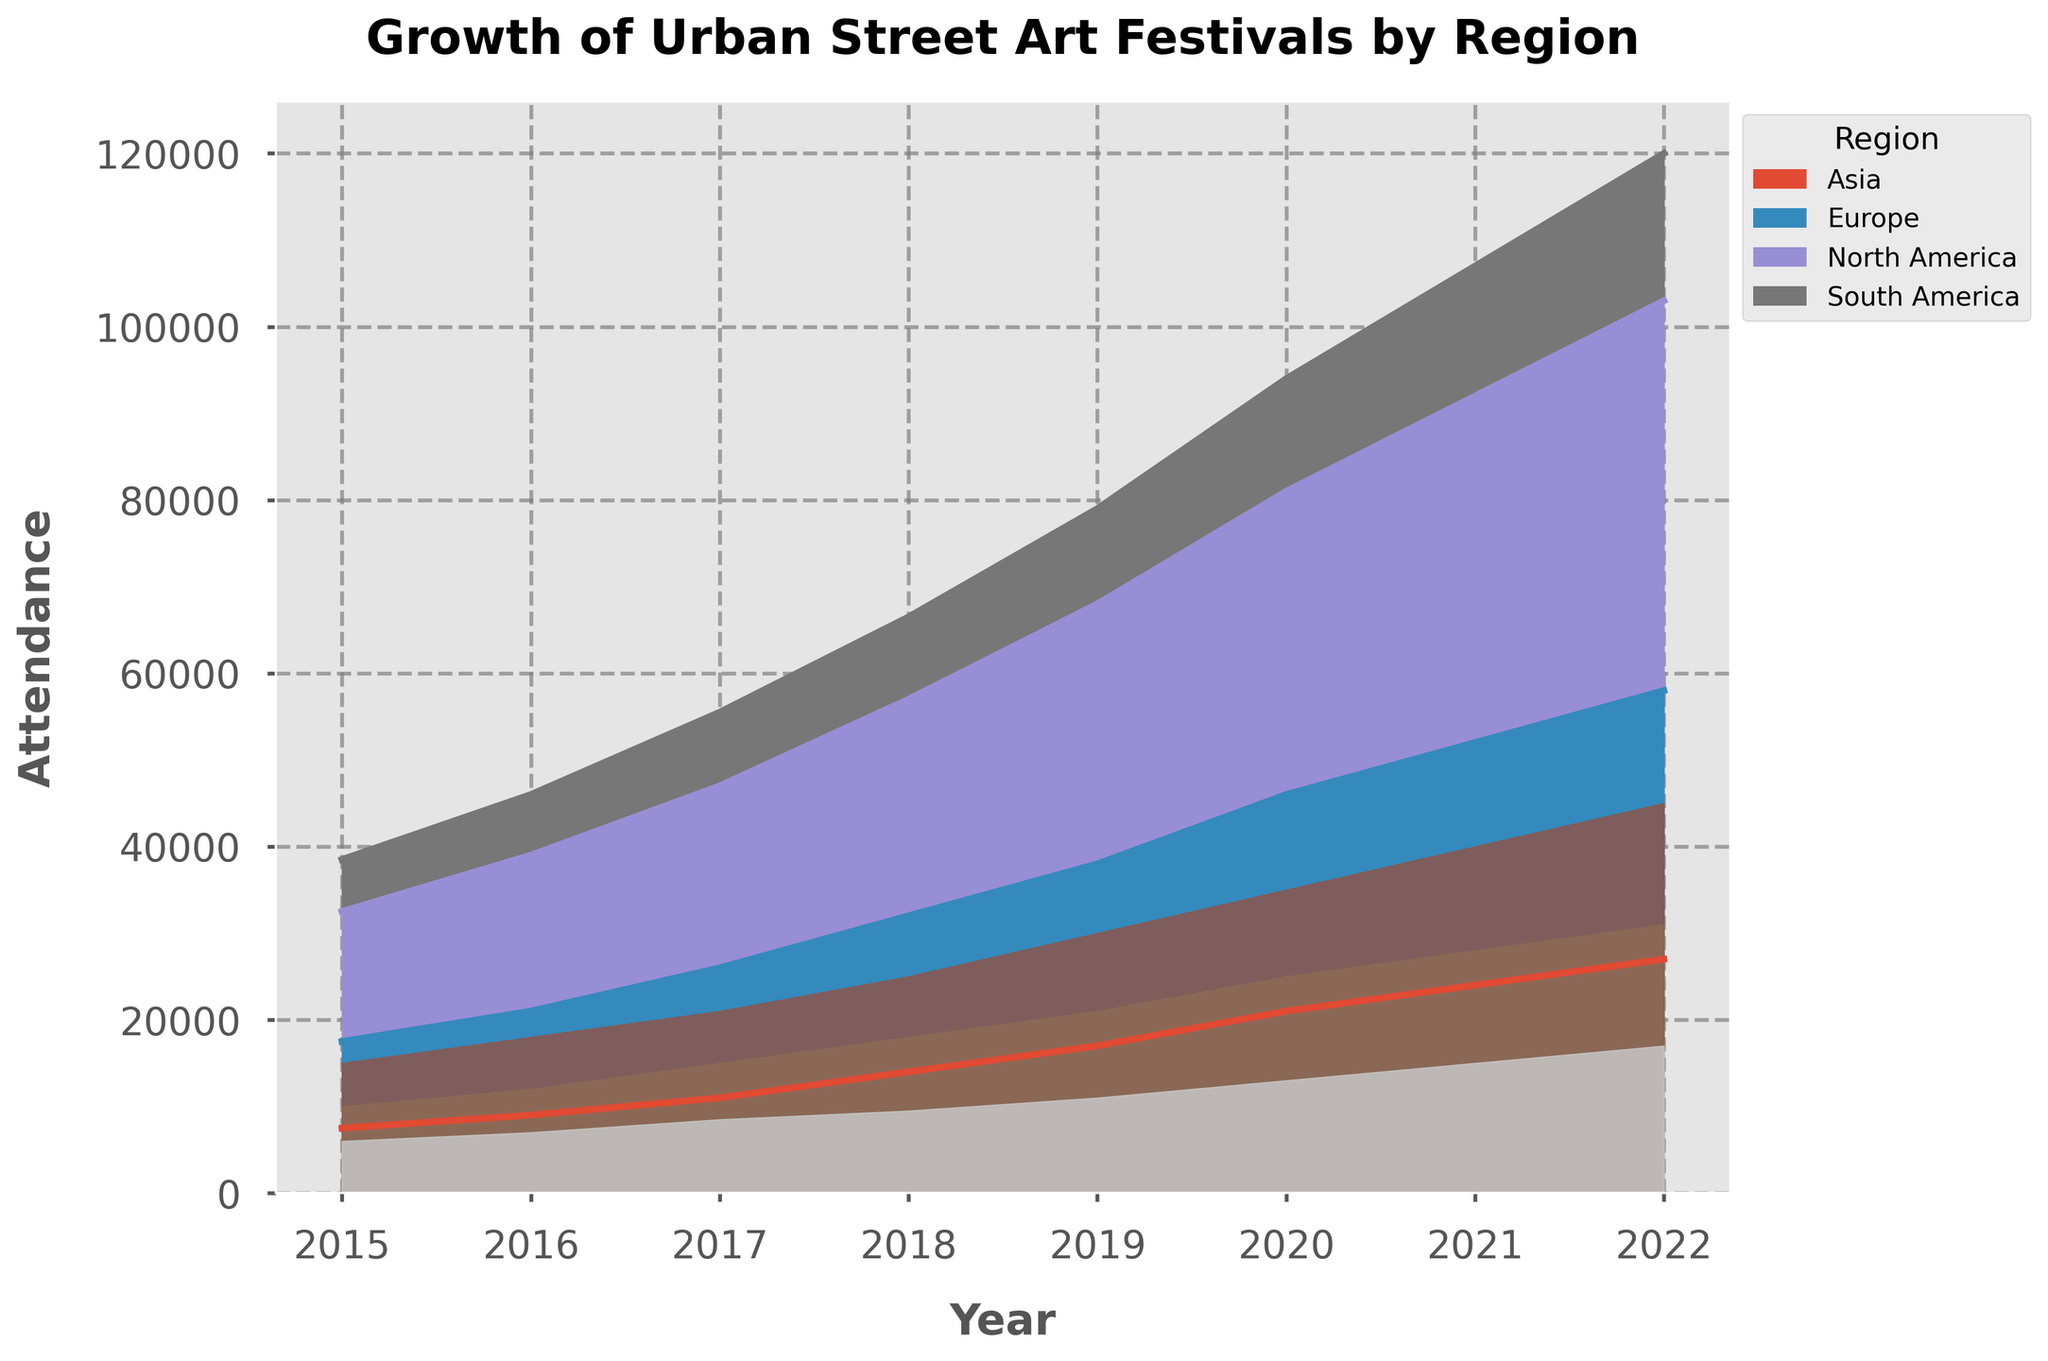What is the overall trend in attendance for Urban Street Art Festivals in North America from 2015 to 2022? By observing the North American section of the area chart, you can see that the attendance is increasing each year from 2015 to 2022. The trend is upwards.
Answer: Increasing Which year had the highest total attendance across all regions? Looking at the total height of all stacked areas combined, 2022 appears to have the highest attendance among all regions.
Answer: 2022 Compare the attendance growth between Europe and South America from 2015 to 2022. Which region experienced more growth? In 2015, Europe had an attendance of 10,000, and in 2022, it had 31,000, showing an increase of 21,000. South America had 6,000 in 2015 and 17,000 in 2022, an increase of 11,000. Therefore, Europe had a larger growth.
Answer: Europe Calculate the average attendance growth per year for Asia between 2015 and 2022. The attendance in Asia grew from 7,500 in 2015 to 27,000 in 2022: the growth is 19,500. To find the average annual growth, divide 19,500 by the number of years (7). 19,500 / 7 = 2,785.71.
Answer: 2,785.71 How does the attendance for South America in 2019 compare to that in 2022? South America's attendance was 11,000 in 2019 and 17,000 in 2022. Therefore, the attendance increased by 6,000 between these years.
Answer: Increased by 6,000 Between which consecutive years did North America experience the highest increase in attendance? By comparing the differences in North America's attendance between consecutive years: 2015-2016 (3,000), 2016-2017 (3,000), 2017-2018 (4,000), 2018-2019 (5,000), 2019-2020 (5,000), 2020-2021 (5,000), 2021-2022 (5,000), it is clear that the largest increase (5,000) occurred between 2019 and 2020 as well as in the next consecutive years (2020-2021 and 2021-2022).
Answer: 2019-2020 In 2018, which region had the highest attendance and how much higher was it compared to the region with the lowest attendance? From the chart, North America had the highest attendance in 2018 with 25,000, while South America had the lowest with 9,500. The difference is 25,000 - 9,500 = 15,500.
Answer: North America, 15,500 What percentage of the total attendance in 2021 was from Asia? Looking at the stacked area chart for 2021, Asia had an attendance of 24,000. Summing up all the regions for 2021 gives 40,000 (North America) + 28,000 (Europe) + 24,000 (Asia) + 15,000 (South America) = 107,000. Therefore, Asia’s percentage is (24,000 / 107,000) * 100 = 22.43%.
Answer: 22.43% 